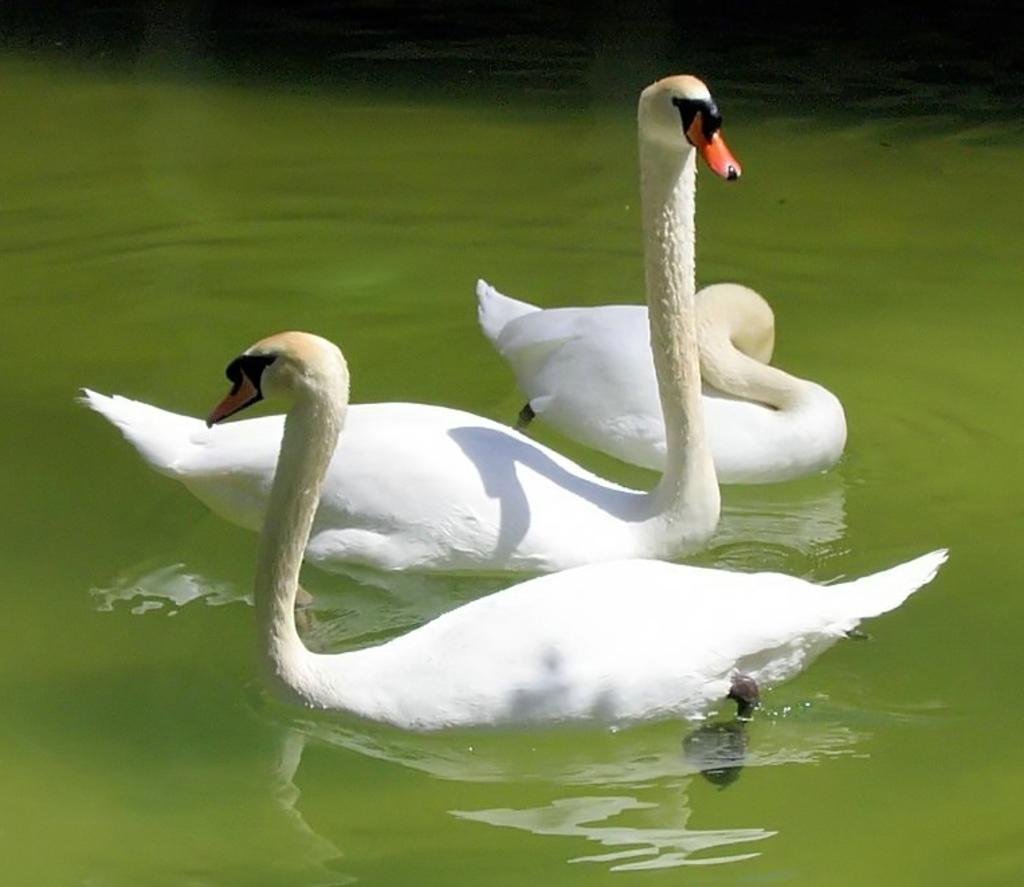Could you give a brief overview of what you see in this image? There is a clear lake. In the middle there are three swans which are white in color. 